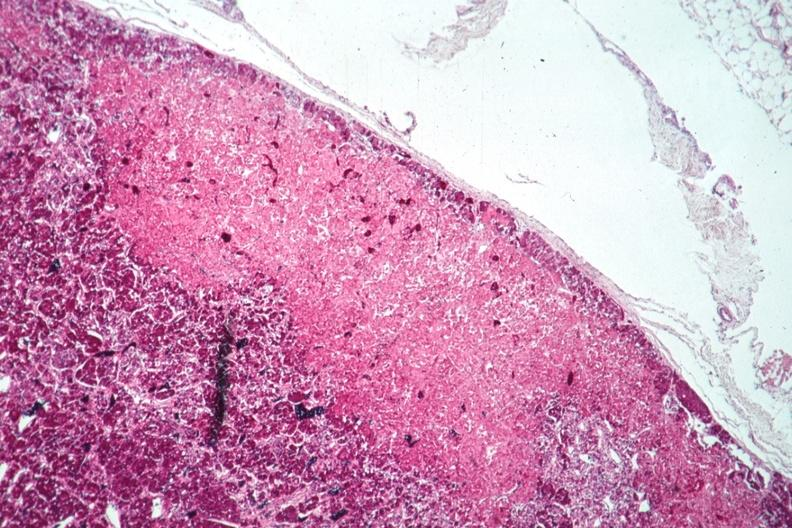what does this image show?
Answer the question using a single word or phrase. Well shown infarct 